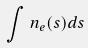<formula> <loc_0><loc_0><loc_500><loc_500>\int n _ { e } ( s ) d s</formula> 